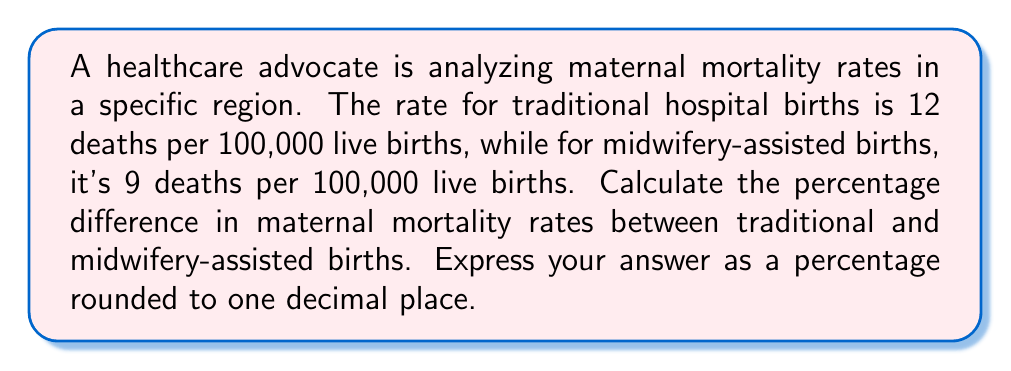Provide a solution to this math problem. To calculate the percentage difference between two values, we use the following formula:

$$ \text{Percentage Difference} = \frac{|\text{Value 1} - \text{Value 2}|}{\frac{\text{Value 1} + \text{Value 2}}{2}} \times 100\% $$

Where:
- Value 1 is the maternal mortality rate for traditional hospital births: 12 per 100,000
- Value 2 is the maternal mortality rate for midwifery-assisted births: 9 per 100,000

Let's substitute these values into the formula:

$$ \text{Percentage Difference} = \frac{|12 - 9|}{\frac{12 + 9}{2}} \times 100\% $$

$$ = \frac{3}{\frac{21}{2}} \times 100\% $$

$$ = \frac{3}{\frac{21}{2}} \times 100\% $$

$$ = \frac{3 \times 2}{21} \times 100\% $$

$$ = \frac{6}{21} \times 100\% $$

$$ \approx 0.2857 \times 100\% $$

$$ \approx 28.57\% $$

Rounding to one decimal place, we get 28.6%.
Answer: 28.6% 